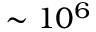Convert formula to latex. <formula><loc_0><loc_0><loc_500><loc_500>\sim 1 0 ^ { 6 }</formula> 